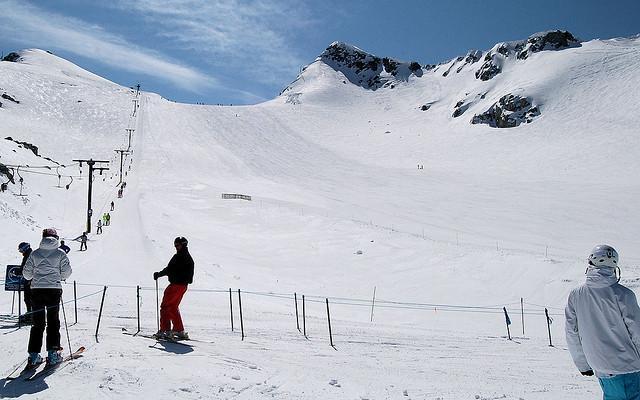How many people are there?
Give a very brief answer. 3. 